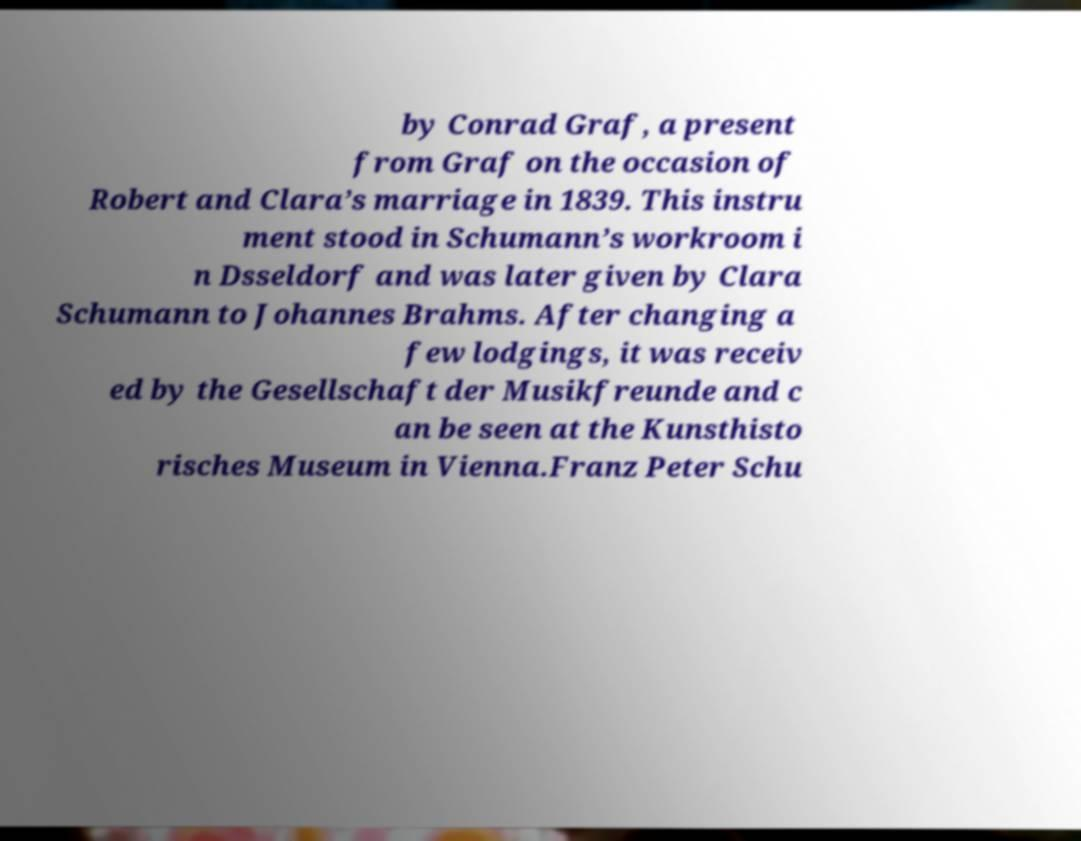Please identify and transcribe the text found in this image. by Conrad Graf, a present from Graf on the occasion of Robert and Clara’s marriage in 1839. This instru ment stood in Schumann’s workroom i n Dsseldorf and was later given by Clara Schumann to Johannes Brahms. After changing a few lodgings, it was receiv ed by the Gesellschaft der Musikfreunde and c an be seen at the Kunsthisto risches Museum in Vienna.Franz Peter Schu 